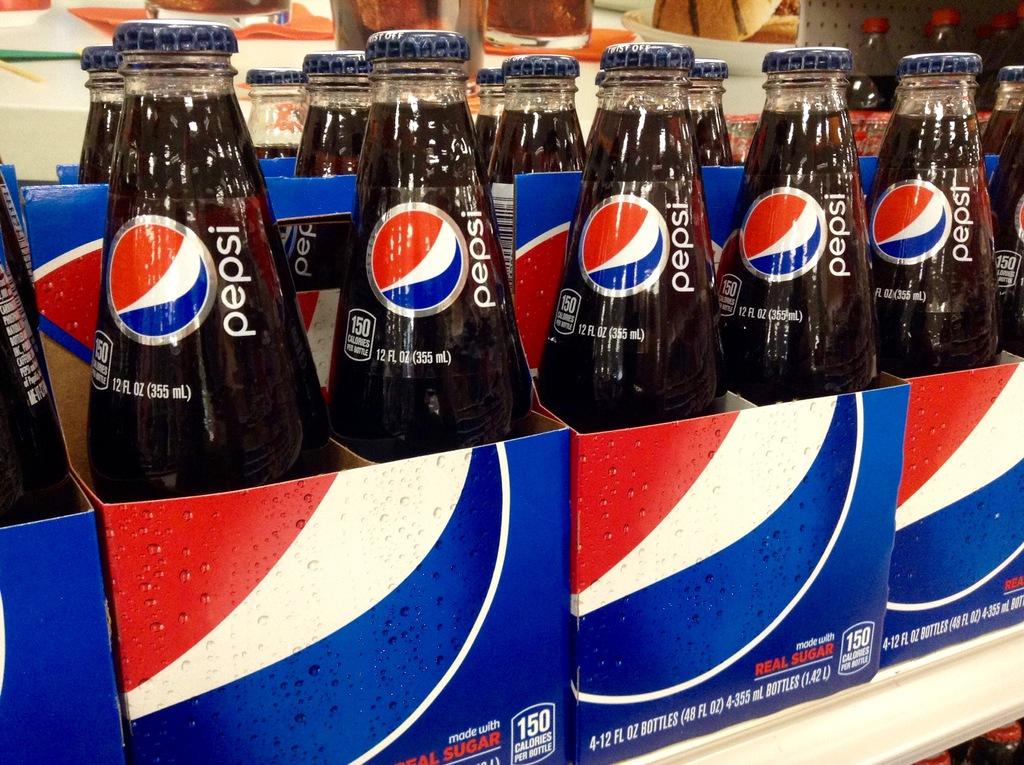What non-coke product is pictured here?
Offer a terse response. Pepsi. Is this the full sugar pepsi?
Your response must be concise. Yes. 